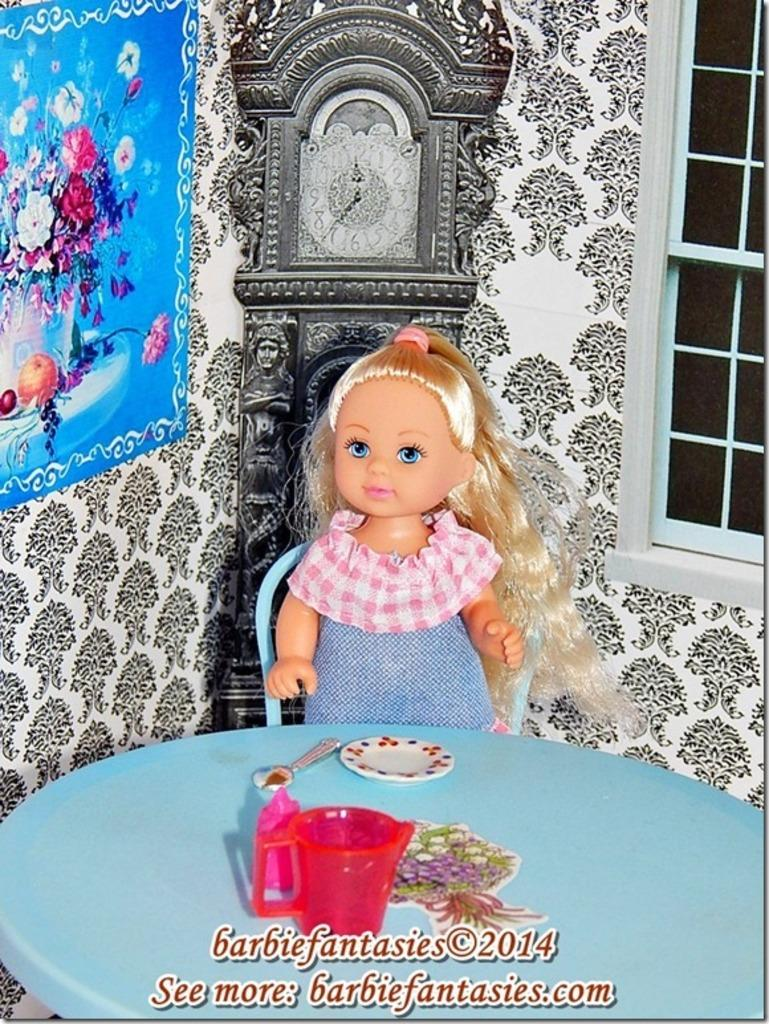What is the doll doing in the image? The doll is sitting on a chair in the image. What is located in front of the doll? There is a table in front of the doll. What items can be seen on the table? There is a mug, a plate, and a spoon on the table. What time-related object is present in the image? There is a clock in the image. What type of decoration is on the wall? There is a flower poster on a wall. What architectural feature is visible in the image? There is a window in the image. What type of mitten is the doll wearing in the image? There is no mitten present in the image; the doll is not wearing any clothing or accessories. 